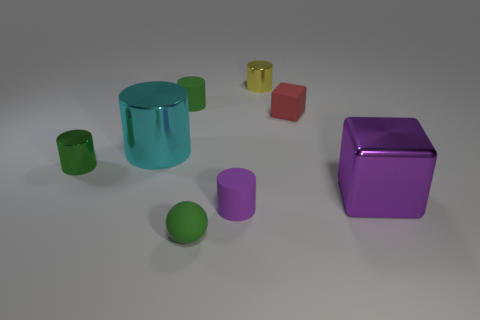Is the number of big yellow shiny blocks greater than the number of tiny yellow metal cylinders?
Give a very brief answer. No. There is a big thing that is on the left side of the yellow metallic cylinder; what shape is it?
Offer a very short reply. Cylinder. How many big yellow things have the same shape as the large cyan metal object?
Offer a terse response. 0. There is a green matte thing behind the green rubber thing that is in front of the small red rubber object; what size is it?
Your response must be concise. Small. What number of green objects are either small matte things or tiny things?
Keep it short and to the point. 3. Are there fewer tiny blocks in front of the cyan cylinder than tiny green objects in front of the red block?
Ensure brevity in your answer.  Yes. There is a green shiny cylinder; is it the same size as the cube in front of the green shiny thing?
Your answer should be very brief. No. How many green matte spheres have the same size as the yellow shiny cylinder?
Your answer should be compact. 1. What number of tiny objects are either metal things or purple things?
Offer a terse response. 3. Is there a metal thing?
Provide a short and direct response. Yes. 